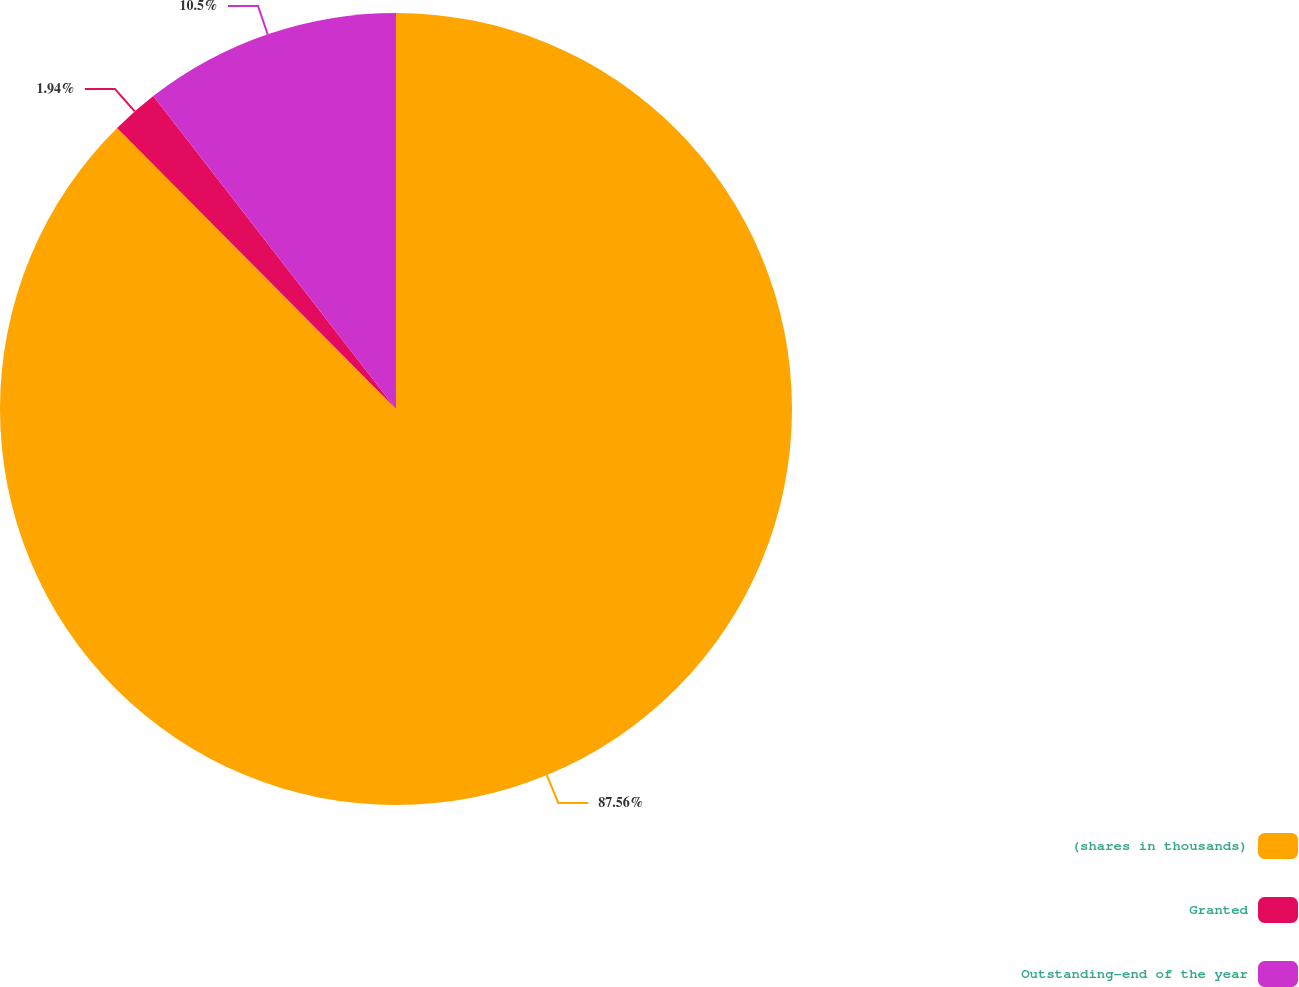Convert chart. <chart><loc_0><loc_0><loc_500><loc_500><pie_chart><fcel>(shares in thousands)<fcel>Granted<fcel>Outstanding-end of the year<nl><fcel>87.56%<fcel>1.94%<fcel>10.5%<nl></chart> 